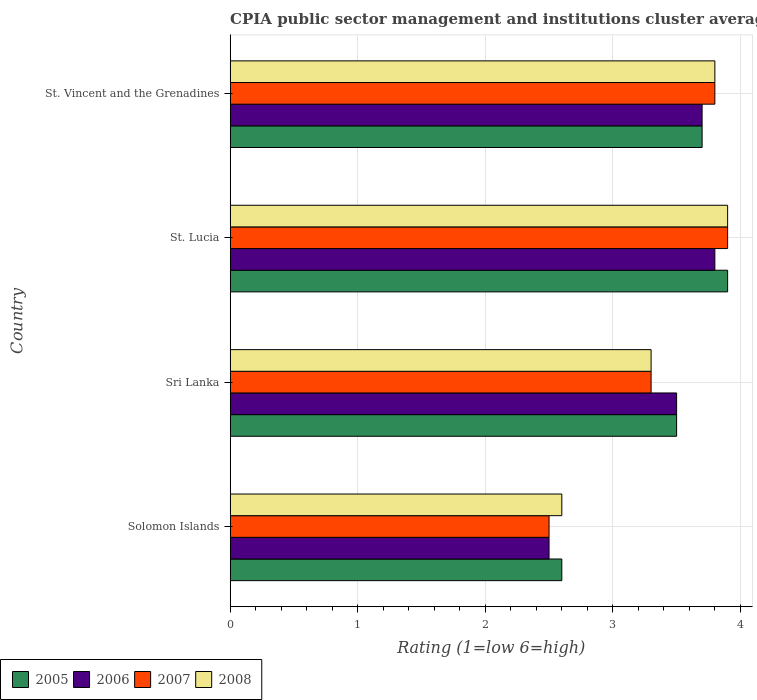How many groups of bars are there?
Make the answer very short. 4. Are the number of bars on each tick of the Y-axis equal?
Make the answer very short. Yes. How many bars are there on the 2nd tick from the top?
Provide a succinct answer. 4. What is the label of the 1st group of bars from the top?
Provide a short and direct response. St. Vincent and the Grenadines. In how many cases, is the number of bars for a given country not equal to the number of legend labels?
Offer a terse response. 0. Across all countries, what is the minimum CPIA rating in 2008?
Offer a very short reply. 2.6. In which country was the CPIA rating in 2007 maximum?
Keep it short and to the point. St. Lucia. In which country was the CPIA rating in 2005 minimum?
Your answer should be very brief. Solomon Islands. What is the total CPIA rating in 2006 in the graph?
Offer a very short reply. 13.5. What is the difference between the CPIA rating in 2007 in Sri Lanka and that in St. Lucia?
Your answer should be compact. -0.6. What is the difference between the CPIA rating in 2007 in St. Vincent and the Grenadines and the CPIA rating in 2006 in Sri Lanka?
Your answer should be compact. 0.3. What is the average CPIA rating in 2008 per country?
Your response must be concise. 3.4. What is the difference between the CPIA rating in 2008 and CPIA rating in 2007 in St. Lucia?
Your answer should be very brief. 0. In how many countries, is the CPIA rating in 2008 greater than 2.8 ?
Offer a very short reply. 3. What is the ratio of the CPIA rating in 2007 in Solomon Islands to that in St. Vincent and the Grenadines?
Give a very brief answer. 0.66. Is the difference between the CPIA rating in 2008 in Solomon Islands and Sri Lanka greater than the difference between the CPIA rating in 2007 in Solomon Islands and Sri Lanka?
Offer a very short reply. Yes. What is the difference between the highest and the second highest CPIA rating in 2007?
Your answer should be very brief. 0.1. What is the difference between the highest and the lowest CPIA rating in 2005?
Your response must be concise. 1.3. Is the sum of the CPIA rating in 2005 in Solomon Islands and St. Vincent and the Grenadines greater than the maximum CPIA rating in 2006 across all countries?
Your response must be concise. Yes. Is it the case that in every country, the sum of the CPIA rating in 2007 and CPIA rating in 2008 is greater than the sum of CPIA rating in 2006 and CPIA rating in 2005?
Keep it short and to the point. No. What does the 1st bar from the bottom in Solomon Islands represents?
Ensure brevity in your answer.  2005. How many bars are there?
Provide a short and direct response. 16. Are the values on the major ticks of X-axis written in scientific E-notation?
Ensure brevity in your answer.  No. Does the graph contain any zero values?
Provide a succinct answer. No. Does the graph contain grids?
Offer a very short reply. Yes. Where does the legend appear in the graph?
Keep it short and to the point. Bottom left. What is the title of the graph?
Provide a succinct answer. CPIA public sector management and institutions cluster average. What is the label or title of the Y-axis?
Keep it short and to the point. Country. What is the Rating (1=low 6=high) of 2005 in Solomon Islands?
Your response must be concise. 2.6. What is the Rating (1=low 6=high) in 2007 in Solomon Islands?
Provide a succinct answer. 2.5. What is the Rating (1=low 6=high) of 2008 in Solomon Islands?
Provide a succinct answer. 2.6. What is the Rating (1=low 6=high) in 2006 in Sri Lanka?
Make the answer very short. 3.5. What is the Rating (1=low 6=high) in 2008 in Sri Lanka?
Ensure brevity in your answer.  3.3. What is the Rating (1=low 6=high) of 2007 in St. Lucia?
Provide a short and direct response. 3.9. What is the Rating (1=low 6=high) in 2005 in St. Vincent and the Grenadines?
Your response must be concise. 3.7. Across all countries, what is the maximum Rating (1=low 6=high) in 2005?
Provide a succinct answer. 3.9. Across all countries, what is the maximum Rating (1=low 6=high) of 2007?
Give a very brief answer. 3.9. Across all countries, what is the minimum Rating (1=low 6=high) in 2006?
Give a very brief answer. 2.5. Across all countries, what is the minimum Rating (1=low 6=high) of 2007?
Provide a succinct answer. 2.5. Across all countries, what is the minimum Rating (1=low 6=high) in 2008?
Your answer should be compact. 2.6. What is the total Rating (1=low 6=high) in 2005 in the graph?
Offer a terse response. 13.7. What is the difference between the Rating (1=low 6=high) of 2008 in Solomon Islands and that in Sri Lanka?
Ensure brevity in your answer.  -0.7. What is the difference between the Rating (1=low 6=high) in 2005 in Solomon Islands and that in St. Lucia?
Give a very brief answer. -1.3. What is the difference between the Rating (1=low 6=high) in 2007 in Solomon Islands and that in St. Lucia?
Provide a short and direct response. -1.4. What is the difference between the Rating (1=low 6=high) of 2008 in Solomon Islands and that in St. Lucia?
Offer a very short reply. -1.3. What is the difference between the Rating (1=low 6=high) in 2005 in Solomon Islands and that in St. Vincent and the Grenadines?
Provide a succinct answer. -1.1. What is the difference between the Rating (1=low 6=high) of 2007 in Solomon Islands and that in St. Vincent and the Grenadines?
Provide a succinct answer. -1.3. What is the difference between the Rating (1=low 6=high) of 2007 in Sri Lanka and that in St. Lucia?
Make the answer very short. -0.6. What is the difference between the Rating (1=low 6=high) of 2008 in Sri Lanka and that in St. Lucia?
Provide a succinct answer. -0.6. What is the difference between the Rating (1=low 6=high) of 2006 in Sri Lanka and that in St. Vincent and the Grenadines?
Provide a succinct answer. -0.2. What is the difference between the Rating (1=low 6=high) of 2007 in Sri Lanka and that in St. Vincent and the Grenadines?
Offer a terse response. -0.5. What is the difference between the Rating (1=low 6=high) of 2007 in St. Lucia and that in St. Vincent and the Grenadines?
Your response must be concise. 0.1. What is the difference between the Rating (1=low 6=high) in 2008 in St. Lucia and that in St. Vincent and the Grenadines?
Offer a terse response. 0.1. What is the difference between the Rating (1=low 6=high) of 2006 in Solomon Islands and the Rating (1=low 6=high) of 2008 in Sri Lanka?
Provide a short and direct response. -0.8. What is the difference between the Rating (1=low 6=high) in 2007 in Solomon Islands and the Rating (1=low 6=high) in 2008 in Sri Lanka?
Give a very brief answer. -0.8. What is the difference between the Rating (1=low 6=high) in 2005 in Solomon Islands and the Rating (1=low 6=high) in 2006 in St. Lucia?
Ensure brevity in your answer.  -1.2. What is the difference between the Rating (1=low 6=high) of 2005 in Solomon Islands and the Rating (1=low 6=high) of 2008 in St. Lucia?
Your response must be concise. -1.3. What is the difference between the Rating (1=low 6=high) in 2006 in Solomon Islands and the Rating (1=low 6=high) in 2007 in St. Lucia?
Make the answer very short. -1.4. What is the difference between the Rating (1=low 6=high) of 2006 in Solomon Islands and the Rating (1=low 6=high) of 2008 in St. Lucia?
Your answer should be very brief. -1.4. What is the difference between the Rating (1=low 6=high) of 2005 in Solomon Islands and the Rating (1=low 6=high) of 2007 in St. Vincent and the Grenadines?
Offer a terse response. -1.2. What is the difference between the Rating (1=low 6=high) in 2005 in Solomon Islands and the Rating (1=low 6=high) in 2008 in St. Vincent and the Grenadines?
Keep it short and to the point. -1.2. What is the difference between the Rating (1=low 6=high) in 2006 in Solomon Islands and the Rating (1=low 6=high) in 2008 in St. Vincent and the Grenadines?
Give a very brief answer. -1.3. What is the difference between the Rating (1=low 6=high) of 2007 in Solomon Islands and the Rating (1=low 6=high) of 2008 in St. Vincent and the Grenadines?
Offer a very short reply. -1.3. What is the difference between the Rating (1=low 6=high) of 2005 in Sri Lanka and the Rating (1=low 6=high) of 2008 in St. Lucia?
Your answer should be very brief. -0.4. What is the difference between the Rating (1=low 6=high) of 2006 in Sri Lanka and the Rating (1=low 6=high) of 2007 in St. Lucia?
Your answer should be compact. -0.4. What is the difference between the Rating (1=low 6=high) of 2006 in Sri Lanka and the Rating (1=low 6=high) of 2008 in St. Lucia?
Your answer should be compact. -0.4. What is the difference between the Rating (1=low 6=high) of 2005 in Sri Lanka and the Rating (1=low 6=high) of 2006 in St. Vincent and the Grenadines?
Your response must be concise. -0.2. What is the difference between the Rating (1=low 6=high) of 2005 in Sri Lanka and the Rating (1=low 6=high) of 2008 in St. Vincent and the Grenadines?
Your response must be concise. -0.3. What is the difference between the Rating (1=low 6=high) in 2006 in Sri Lanka and the Rating (1=low 6=high) in 2008 in St. Vincent and the Grenadines?
Your response must be concise. -0.3. What is the difference between the Rating (1=low 6=high) in 2005 in St. Lucia and the Rating (1=low 6=high) in 2008 in St. Vincent and the Grenadines?
Offer a very short reply. 0.1. What is the average Rating (1=low 6=high) of 2005 per country?
Provide a short and direct response. 3.42. What is the average Rating (1=low 6=high) in 2006 per country?
Keep it short and to the point. 3.38. What is the average Rating (1=low 6=high) in 2007 per country?
Provide a short and direct response. 3.38. What is the average Rating (1=low 6=high) of 2008 per country?
Your response must be concise. 3.4. What is the difference between the Rating (1=low 6=high) in 2006 and Rating (1=low 6=high) in 2007 in Solomon Islands?
Ensure brevity in your answer.  0. What is the difference between the Rating (1=low 6=high) in 2006 and Rating (1=low 6=high) in 2008 in Solomon Islands?
Provide a short and direct response. -0.1. What is the difference between the Rating (1=low 6=high) in 2007 and Rating (1=low 6=high) in 2008 in Solomon Islands?
Offer a very short reply. -0.1. What is the difference between the Rating (1=low 6=high) of 2005 and Rating (1=low 6=high) of 2006 in Sri Lanka?
Provide a succinct answer. 0. What is the difference between the Rating (1=low 6=high) of 2005 and Rating (1=low 6=high) of 2007 in Sri Lanka?
Make the answer very short. 0.2. What is the difference between the Rating (1=low 6=high) of 2005 and Rating (1=low 6=high) of 2008 in Sri Lanka?
Offer a terse response. 0.2. What is the difference between the Rating (1=low 6=high) in 2006 and Rating (1=low 6=high) in 2008 in Sri Lanka?
Ensure brevity in your answer.  0.2. What is the difference between the Rating (1=low 6=high) in 2006 and Rating (1=low 6=high) in 2007 in St. Lucia?
Your response must be concise. -0.1. What is the difference between the Rating (1=low 6=high) in 2007 and Rating (1=low 6=high) in 2008 in St. Lucia?
Give a very brief answer. 0. What is the difference between the Rating (1=low 6=high) in 2006 and Rating (1=low 6=high) in 2007 in St. Vincent and the Grenadines?
Give a very brief answer. -0.1. What is the difference between the Rating (1=low 6=high) in 2006 and Rating (1=low 6=high) in 2008 in St. Vincent and the Grenadines?
Provide a succinct answer. -0.1. What is the ratio of the Rating (1=low 6=high) of 2005 in Solomon Islands to that in Sri Lanka?
Make the answer very short. 0.74. What is the ratio of the Rating (1=low 6=high) of 2007 in Solomon Islands to that in Sri Lanka?
Make the answer very short. 0.76. What is the ratio of the Rating (1=low 6=high) in 2008 in Solomon Islands to that in Sri Lanka?
Provide a succinct answer. 0.79. What is the ratio of the Rating (1=low 6=high) of 2005 in Solomon Islands to that in St. Lucia?
Offer a terse response. 0.67. What is the ratio of the Rating (1=low 6=high) in 2006 in Solomon Islands to that in St. Lucia?
Keep it short and to the point. 0.66. What is the ratio of the Rating (1=low 6=high) of 2007 in Solomon Islands to that in St. Lucia?
Give a very brief answer. 0.64. What is the ratio of the Rating (1=low 6=high) in 2008 in Solomon Islands to that in St. Lucia?
Your answer should be very brief. 0.67. What is the ratio of the Rating (1=low 6=high) in 2005 in Solomon Islands to that in St. Vincent and the Grenadines?
Make the answer very short. 0.7. What is the ratio of the Rating (1=low 6=high) of 2006 in Solomon Islands to that in St. Vincent and the Grenadines?
Provide a short and direct response. 0.68. What is the ratio of the Rating (1=low 6=high) in 2007 in Solomon Islands to that in St. Vincent and the Grenadines?
Provide a succinct answer. 0.66. What is the ratio of the Rating (1=low 6=high) in 2008 in Solomon Islands to that in St. Vincent and the Grenadines?
Your answer should be compact. 0.68. What is the ratio of the Rating (1=low 6=high) of 2005 in Sri Lanka to that in St. Lucia?
Provide a short and direct response. 0.9. What is the ratio of the Rating (1=low 6=high) of 2006 in Sri Lanka to that in St. Lucia?
Give a very brief answer. 0.92. What is the ratio of the Rating (1=low 6=high) of 2007 in Sri Lanka to that in St. Lucia?
Your answer should be compact. 0.85. What is the ratio of the Rating (1=low 6=high) in 2008 in Sri Lanka to that in St. Lucia?
Provide a succinct answer. 0.85. What is the ratio of the Rating (1=low 6=high) in 2005 in Sri Lanka to that in St. Vincent and the Grenadines?
Offer a terse response. 0.95. What is the ratio of the Rating (1=low 6=high) of 2006 in Sri Lanka to that in St. Vincent and the Grenadines?
Provide a succinct answer. 0.95. What is the ratio of the Rating (1=low 6=high) of 2007 in Sri Lanka to that in St. Vincent and the Grenadines?
Provide a succinct answer. 0.87. What is the ratio of the Rating (1=low 6=high) in 2008 in Sri Lanka to that in St. Vincent and the Grenadines?
Offer a very short reply. 0.87. What is the ratio of the Rating (1=low 6=high) in 2005 in St. Lucia to that in St. Vincent and the Grenadines?
Offer a terse response. 1.05. What is the ratio of the Rating (1=low 6=high) in 2007 in St. Lucia to that in St. Vincent and the Grenadines?
Provide a succinct answer. 1.03. What is the ratio of the Rating (1=low 6=high) of 2008 in St. Lucia to that in St. Vincent and the Grenadines?
Give a very brief answer. 1.03. What is the difference between the highest and the second highest Rating (1=low 6=high) in 2005?
Give a very brief answer. 0.2. What is the difference between the highest and the second highest Rating (1=low 6=high) of 2008?
Provide a succinct answer. 0.1. What is the difference between the highest and the lowest Rating (1=low 6=high) in 2005?
Give a very brief answer. 1.3. What is the difference between the highest and the lowest Rating (1=low 6=high) in 2006?
Ensure brevity in your answer.  1.3. 